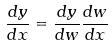Convert formula to latex. <formula><loc_0><loc_0><loc_500><loc_500>\frac { d y } { d x } = \frac { d y } { d w } \frac { d w } { d x }</formula> 